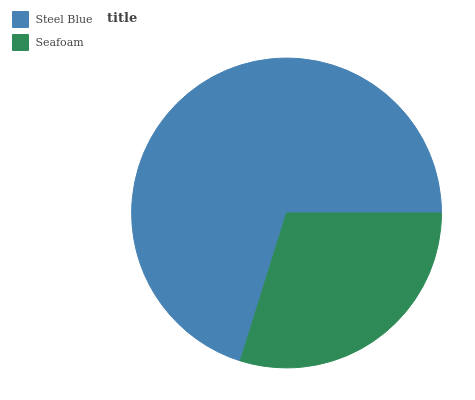Is Seafoam the minimum?
Answer yes or no. Yes. Is Steel Blue the maximum?
Answer yes or no. Yes. Is Seafoam the maximum?
Answer yes or no. No. Is Steel Blue greater than Seafoam?
Answer yes or no. Yes. Is Seafoam less than Steel Blue?
Answer yes or no. Yes. Is Seafoam greater than Steel Blue?
Answer yes or no. No. Is Steel Blue less than Seafoam?
Answer yes or no. No. Is Steel Blue the high median?
Answer yes or no. Yes. Is Seafoam the low median?
Answer yes or no. Yes. Is Seafoam the high median?
Answer yes or no. No. Is Steel Blue the low median?
Answer yes or no. No. 